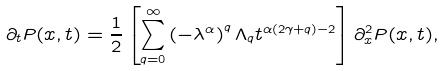<formula> <loc_0><loc_0><loc_500><loc_500>\partial _ { t } P ( x , t ) = \frac { 1 } { 2 } \left [ \sum _ { q = 0 } ^ { \infty } \left ( - \lambda ^ { \alpha } \right ) ^ { q } \Lambda _ { q } t ^ { \alpha ( 2 \gamma + q ) - 2 } \right ] \partial _ { x } ^ { 2 } P ( x , t ) ,</formula> 